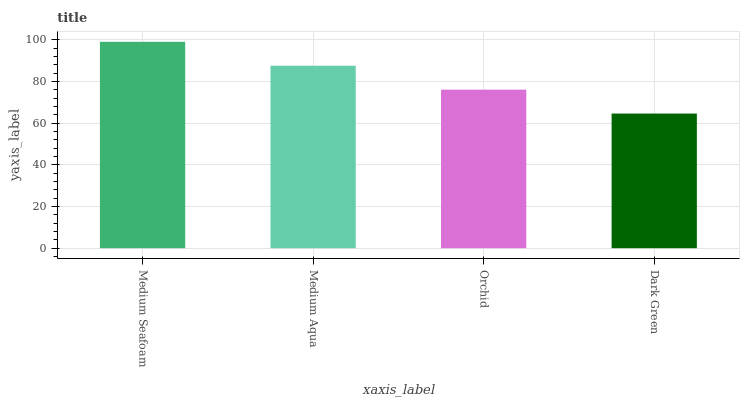Is Dark Green the minimum?
Answer yes or no. Yes. Is Medium Seafoam the maximum?
Answer yes or no. Yes. Is Medium Aqua the minimum?
Answer yes or no. No. Is Medium Aqua the maximum?
Answer yes or no. No. Is Medium Seafoam greater than Medium Aqua?
Answer yes or no. Yes. Is Medium Aqua less than Medium Seafoam?
Answer yes or no. Yes. Is Medium Aqua greater than Medium Seafoam?
Answer yes or no. No. Is Medium Seafoam less than Medium Aqua?
Answer yes or no. No. Is Medium Aqua the high median?
Answer yes or no. Yes. Is Orchid the low median?
Answer yes or no. Yes. Is Orchid the high median?
Answer yes or no. No. Is Medium Seafoam the low median?
Answer yes or no. No. 